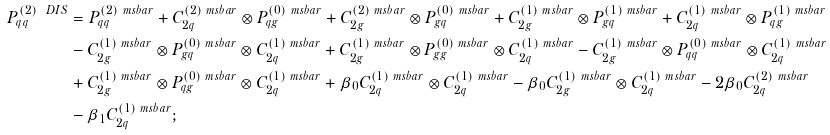Convert formula to latex. <formula><loc_0><loc_0><loc_500><loc_500>P _ { q q } ^ { ( 2 ) \ D I S } & = P _ { q q } ^ { ( 2 ) \ m s b a r } + C _ { 2 q } ^ { ( 2 ) \ m s b a r } \otimes P _ { q g } ^ { ( 0 ) \ m s b a r } + C _ { 2 g } ^ { ( 2 ) \ m s b a r } \otimes P _ { g q } ^ { ( 0 ) \ m s b a r } + C _ { 2 g } ^ { ( 1 ) \ m s b a r } \otimes P _ { g q } ^ { ( 1 ) \ m s b a r } + C _ { 2 q } ^ { ( 1 ) \ m s b a r } \otimes P _ { q g } ^ { ( 1 ) \ m s b a r } \\ & - C _ { 2 g } ^ { ( 1 ) \ m s b a r } \otimes P _ { g q } ^ { ( 0 ) \ m s b a r } \otimes C _ { 2 q } ^ { ( 1 ) \ m s b a r } + C _ { 2 g } ^ { ( 1 ) \ m s b a r } \otimes P _ { g g } ^ { ( 0 ) \ m s b a r } \otimes C _ { 2 q } ^ { ( 1 ) \ m s b a r } - C _ { 2 g } ^ { ( 1 ) \ m s b a r } \otimes P _ { q q } ^ { ( 0 ) \ m s b a r } \otimes C _ { 2 q } ^ { ( 1 ) \ m s b a r } \\ & + C _ { 2 g } ^ { ( 1 ) \ m s b a r } \otimes P _ { q g } ^ { ( 0 ) \ m s b a r } \otimes C _ { 2 q } ^ { ( 1 ) \ m s b a r } + \beta _ { 0 } C _ { 2 q } ^ { ( 1 ) \ m s b a r } \otimes C _ { 2 q } ^ { ( 1 ) \ m s b a r } - \beta _ { 0 } C _ { 2 g } ^ { ( 1 ) \ m s b a r } \otimes C _ { 2 q } ^ { ( 1 ) \ m s b a r } - 2 \beta _ { 0 } C _ { 2 q } ^ { ( 2 ) \ m s b a r } \\ & - \beta _ { 1 } C _ { 2 q } ^ { ( 1 ) \ m s b a r } ;</formula> 